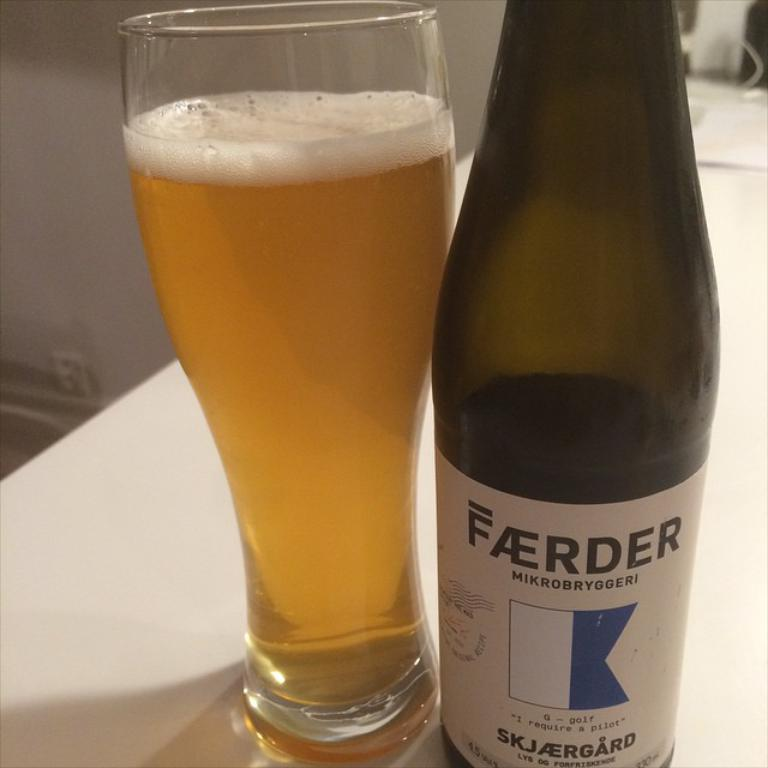What piece of furniture is present in the image? There is a table in the image. What is placed on the table? There is a glass and a bottle on the table. What is inside the glass? The glass is filled with liquid. What type of bird is perched on the bottle in the image? There are no birds present in the image; it only features a table, a glass, and a bottle. 